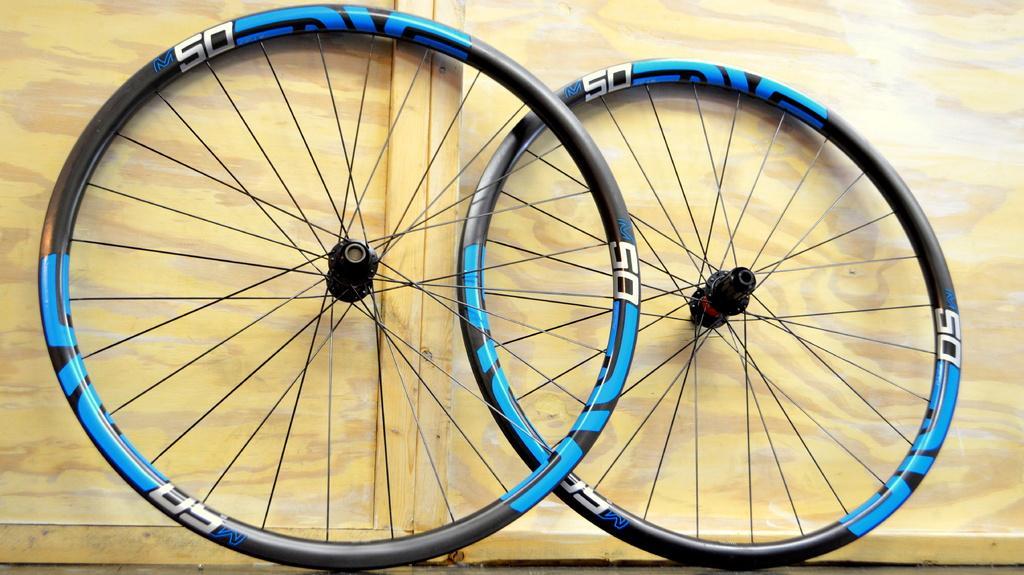In one or two sentences, can you explain what this image depicts? In this image we can see two wheels. 